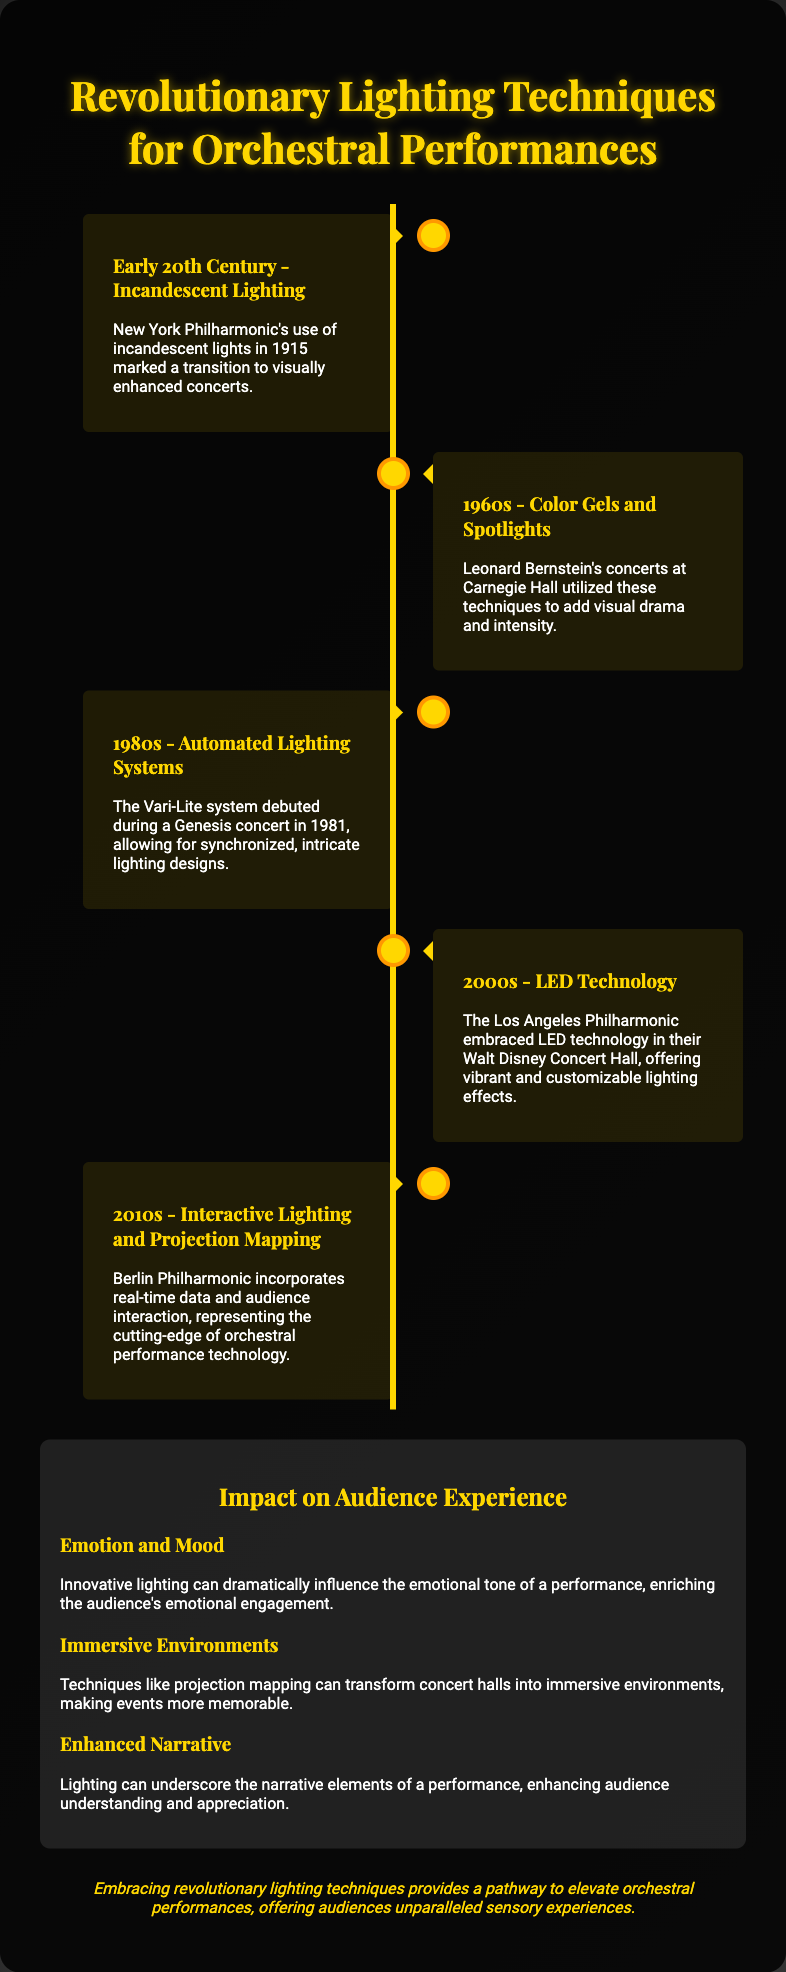What lighting technique was first used by the New York Philharmonic? The document states that the New York Philharmonic used incandescent lights in 1915, marking a transition in orchestral performances.
Answer: Incandescent lights What year did the Vari-Lite system debut? The document mentions that the Vari-Lite system debuted during a Genesis concert in 1981.
Answer: 1981 Which orchestra embraced LED technology in the 2000s? The Los Angeles Philharmonic is noted in the document for embracing LED technology in their Walt Disney Concert Hall.
Answer: Los Angeles Philharmonic What is one emotional effect of innovative lighting mentioned in the document? The document states that innovative lighting can dramatically influence the emotional tone of a performance, enriching the audience's emotional engagement.
Answer: Emotion What type of lighting technique incorporates real-time data? The document states that the Berlin Philharmonic incorporates interactive lighting and projection mapping, which utilize real-time data.
Answer: Interactive lighting What is the central theme of the poster? The poster discusses revolutionary lighting techniques for orchestral performances and their impact on audience experience.
Answer: Lighting techniques How did lighting contribute to the narrative of performances according to the document? The document mentions that lighting can underscore narrative elements, enhancing audience understanding and appreciation.
Answer: Enhance understanding What decade featured the use of color gels and spotlights by Leonard Bernstein? According to the document, Leonard Bernstein's concerts utilized color gels and spotlights in the 1960s.
Answer: 1960s What conclusion does the poster provide about lighting techniques? The conclusion states that embracing revolutionary lighting techniques provides a pathway to elevate orchestral performances, offering unparalleled sensory experiences.
Answer: Elevate performances 